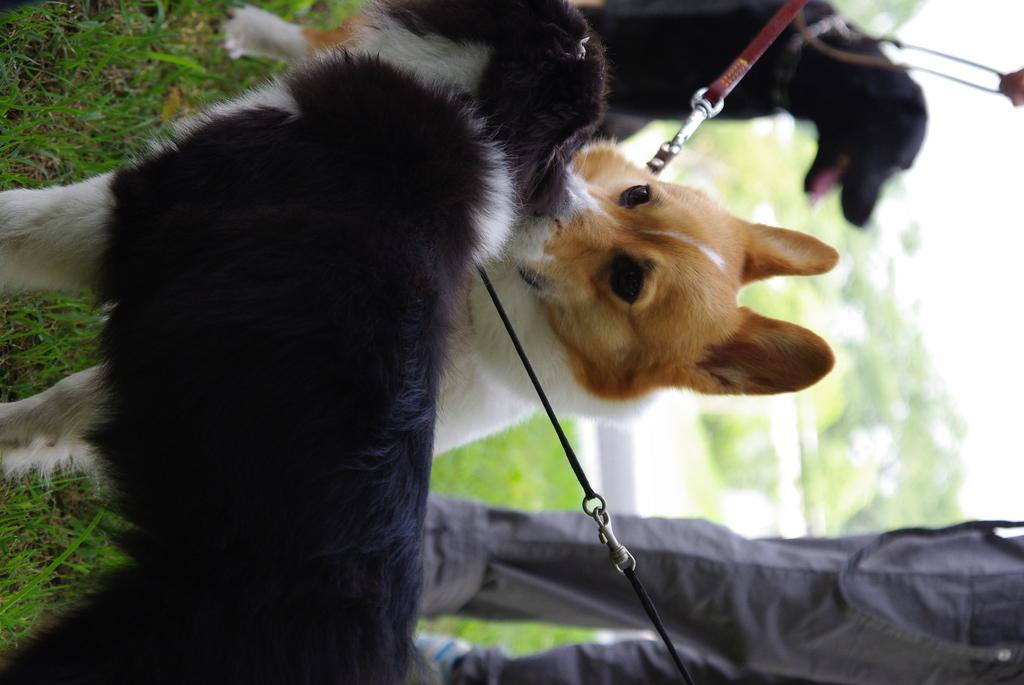What type of animals are in the image? There are dogs in the image. Who is present in the image besides the dogs? There is a person standing in the image. What is the person standing on? The person is standing on the grass. What can be seen in the background of the image? There are trees in the background of the image. How is the background of the image depicted? The background is blurred. What type of beetle can be heard making sounds in the image? There is no beetle or sound present in the image; it features dogs and a person standing on the grass. What organization is responsible for the event depicted in the image? There is no event or organization mentioned in the image; it simply shows dogs, a person, and a grassy area with trees in the background. 